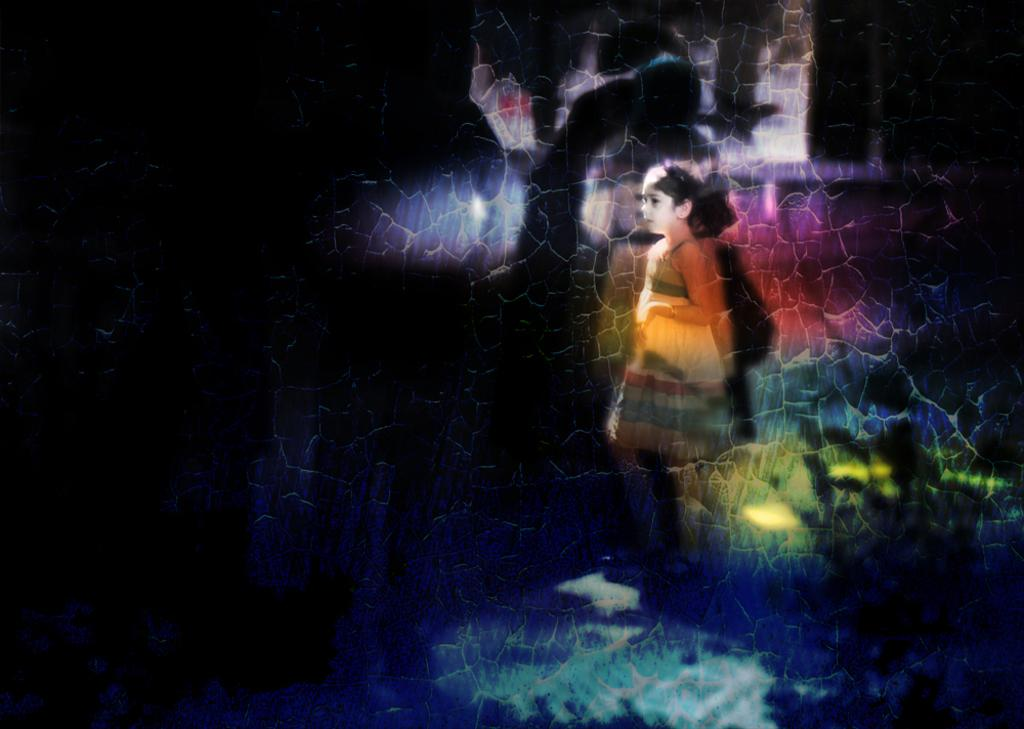What can be said about the nature of the image? The image is edited. Who is present in the image? There is a girl in the image. What is the girl doing in the image? The girl is standing. On which side of the image is the girl located? The girl is on the right side of the image. What type of station can be seen in the background of the image? There is no station present in the image; it only features a girl standing on the right side. Can you describe the farm that is visible in the image? There is no farm present in the image; it is focused on the girl standing on the right side. 